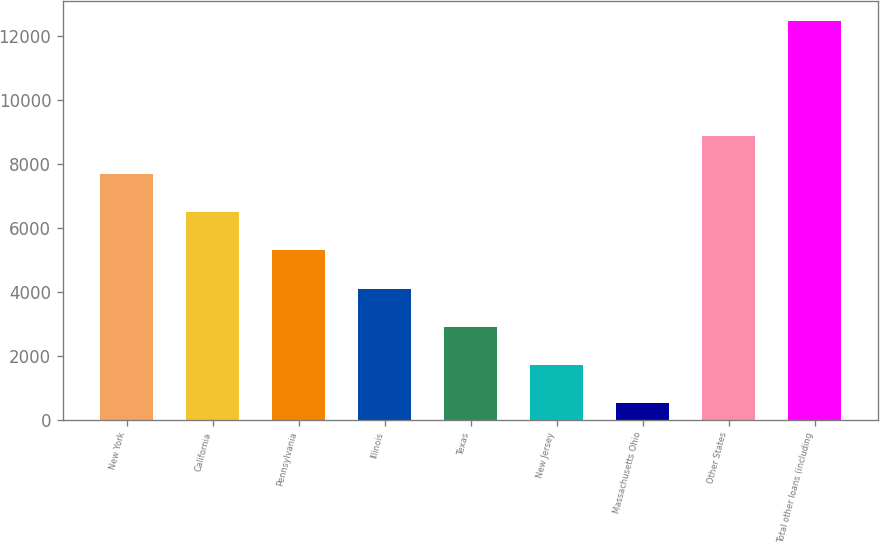Convert chart. <chart><loc_0><loc_0><loc_500><loc_500><bar_chart><fcel>New York<fcel>California<fcel>Pennsylvania<fcel>Illinois<fcel>Texas<fcel>New Jersey<fcel>Massachusetts Ohio<fcel>Other States<fcel>Total other loans (including<nl><fcel>7687<fcel>6490.5<fcel>5294<fcel>4097.5<fcel>2901<fcel>1704.5<fcel>508<fcel>8883.5<fcel>12473<nl></chart> 